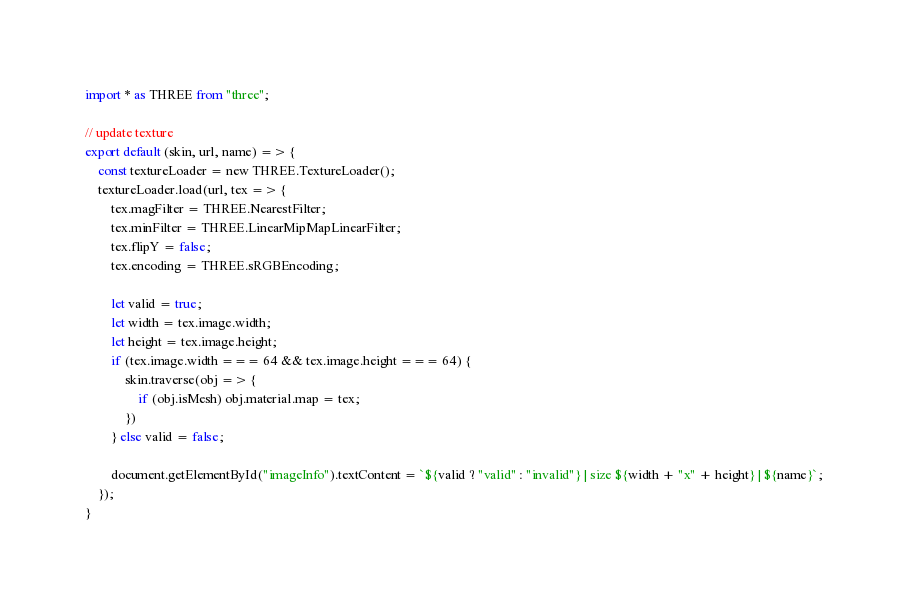<code> <loc_0><loc_0><loc_500><loc_500><_JavaScript_>import * as THREE from "three";

// update texture
export default (skin, url, name) => {
    const textureLoader = new THREE.TextureLoader();
    textureLoader.load(url, tex => {
        tex.magFilter = THREE.NearestFilter;
        tex.minFilter = THREE.LinearMipMapLinearFilter;
        tex.flipY = false;
        tex.encoding = THREE.sRGBEncoding;

        let valid = true;
        let width = tex.image.width;
        let height = tex.image.height;
        if (tex.image.width === 64 && tex.image.height === 64) {
            skin.traverse(obj => {
                if (obj.isMesh) obj.material.map = tex;
            })
        } else valid = false;

        document.getElementById("imageInfo").textContent = `${valid ? "valid" : "invalid"} | size ${width + "x" + height} | ${name}`;
    });
}
</code> 